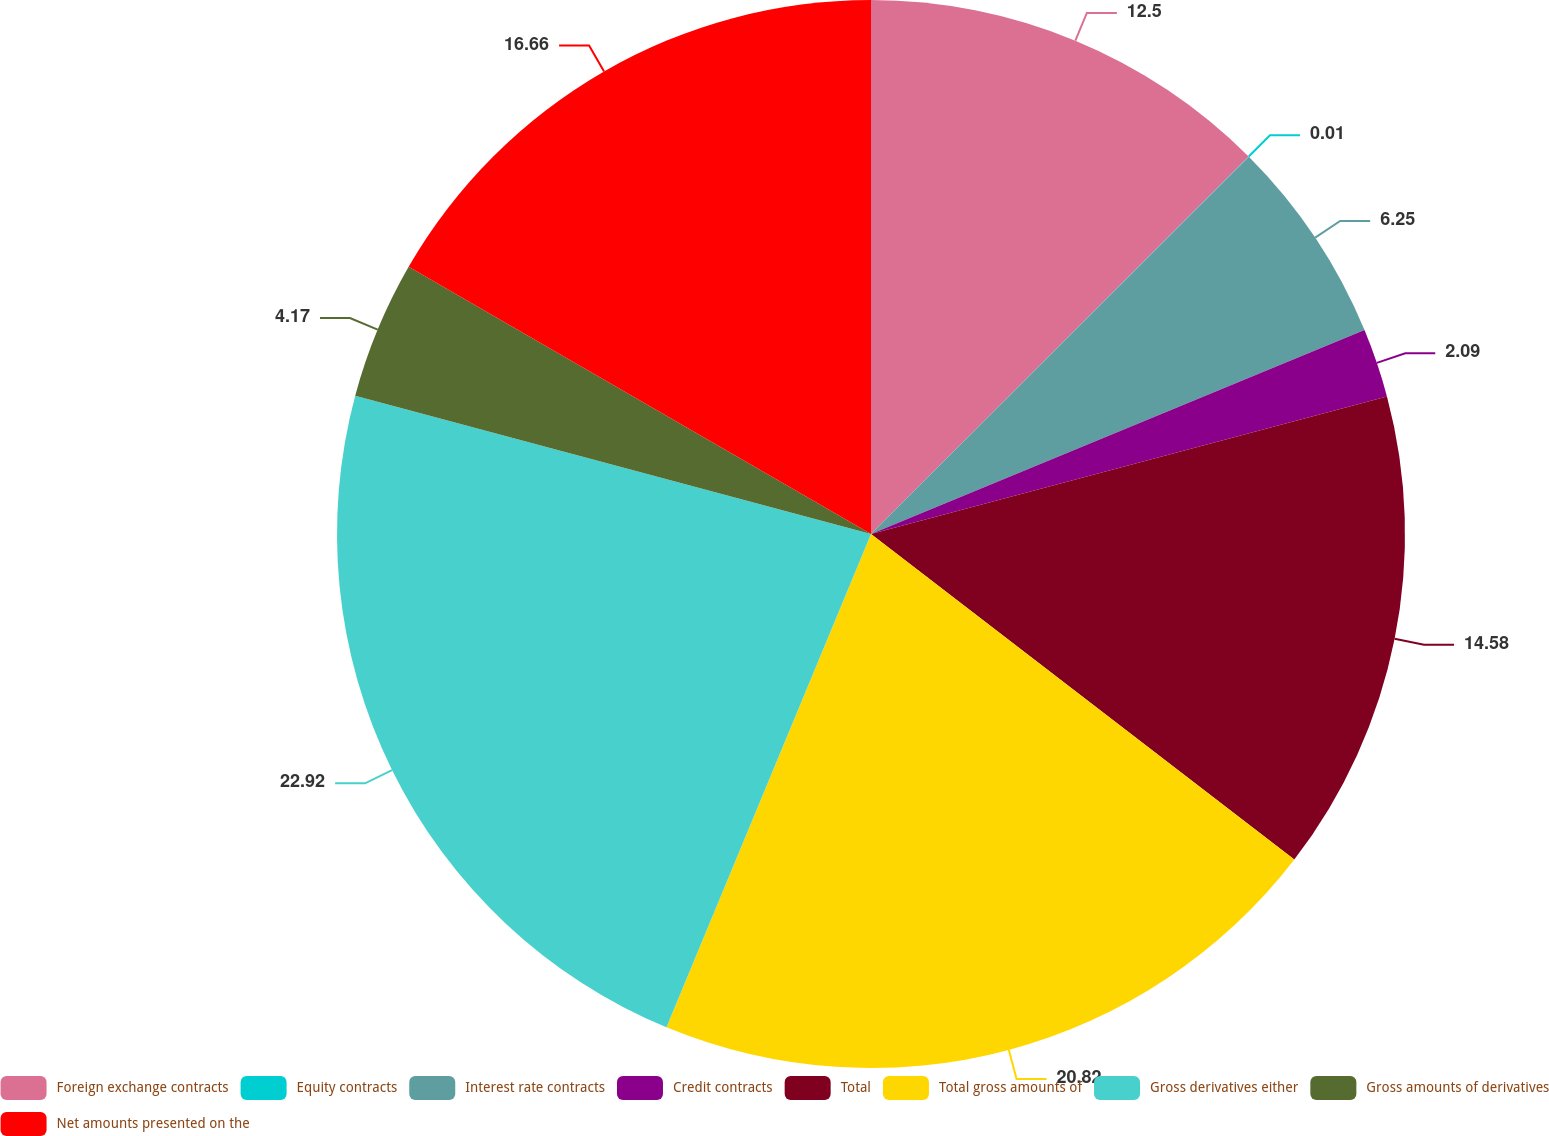Convert chart to OTSL. <chart><loc_0><loc_0><loc_500><loc_500><pie_chart><fcel>Foreign exchange contracts<fcel>Equity contracts<fcel>Interest rate contracts<fcel>Credit contracts<fcel>Total<fcel>Total gross amounts of<fcel>Gross derivatives either<fcel>Gross amounts of derivatives<fcel>Net amounts presented on the<nl><fcel>12.5%<fcel>0.01%<fcel>6.25%<fcel>2.09%<fcel>14.58%<fcel>20.82%<fcel>22.91%<fcel>4.17%<fcel>16.66%<nl></chart> 